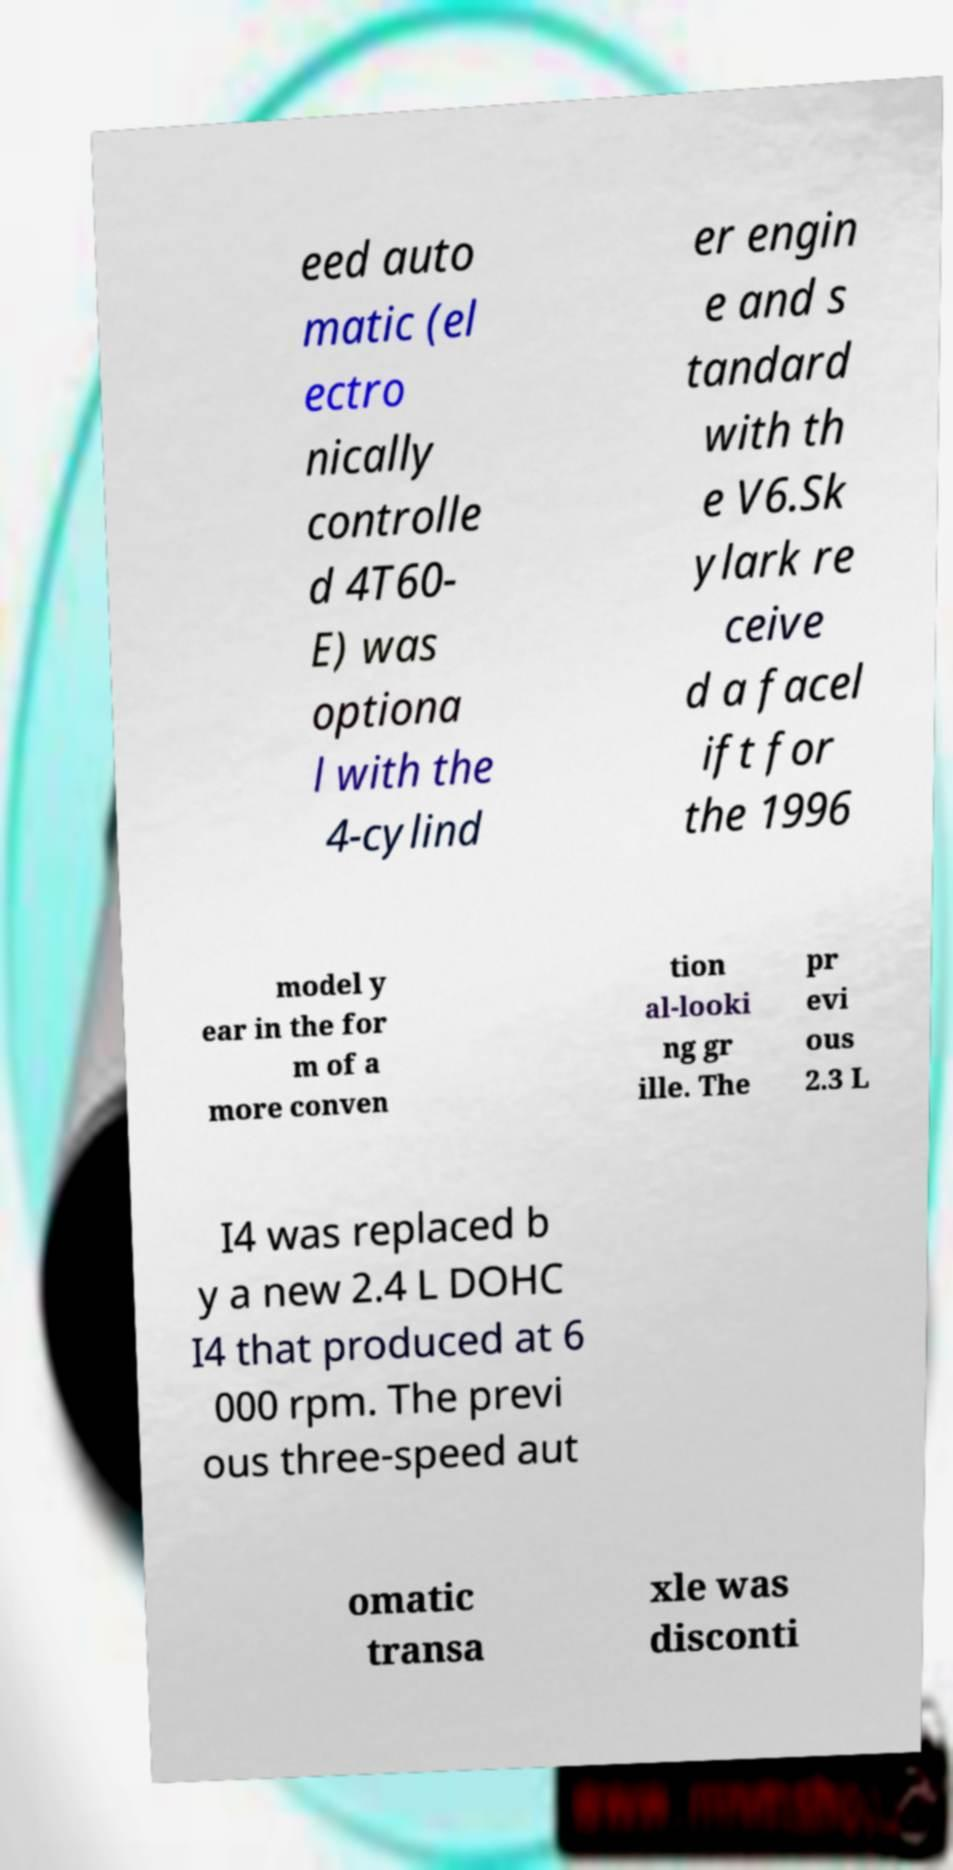Please read and relay the text visible in this image. What does it say? eed auto matic (el ectro nically controlle d 4T60- E) was optiona l with the 4-cylind er engin e and s tandard with th e V6.Sk ylark re ceive d a facel ift for the 1996 model y ear in the for m of a more conven tion al-looki ng gr ille. The pr evi ous 2.3 L I4 was replaced b y a new 2.4 L DOHC I4 that produced at 6 000 rpm. The previ ous three-speed aut omatic transa xle was disconti 